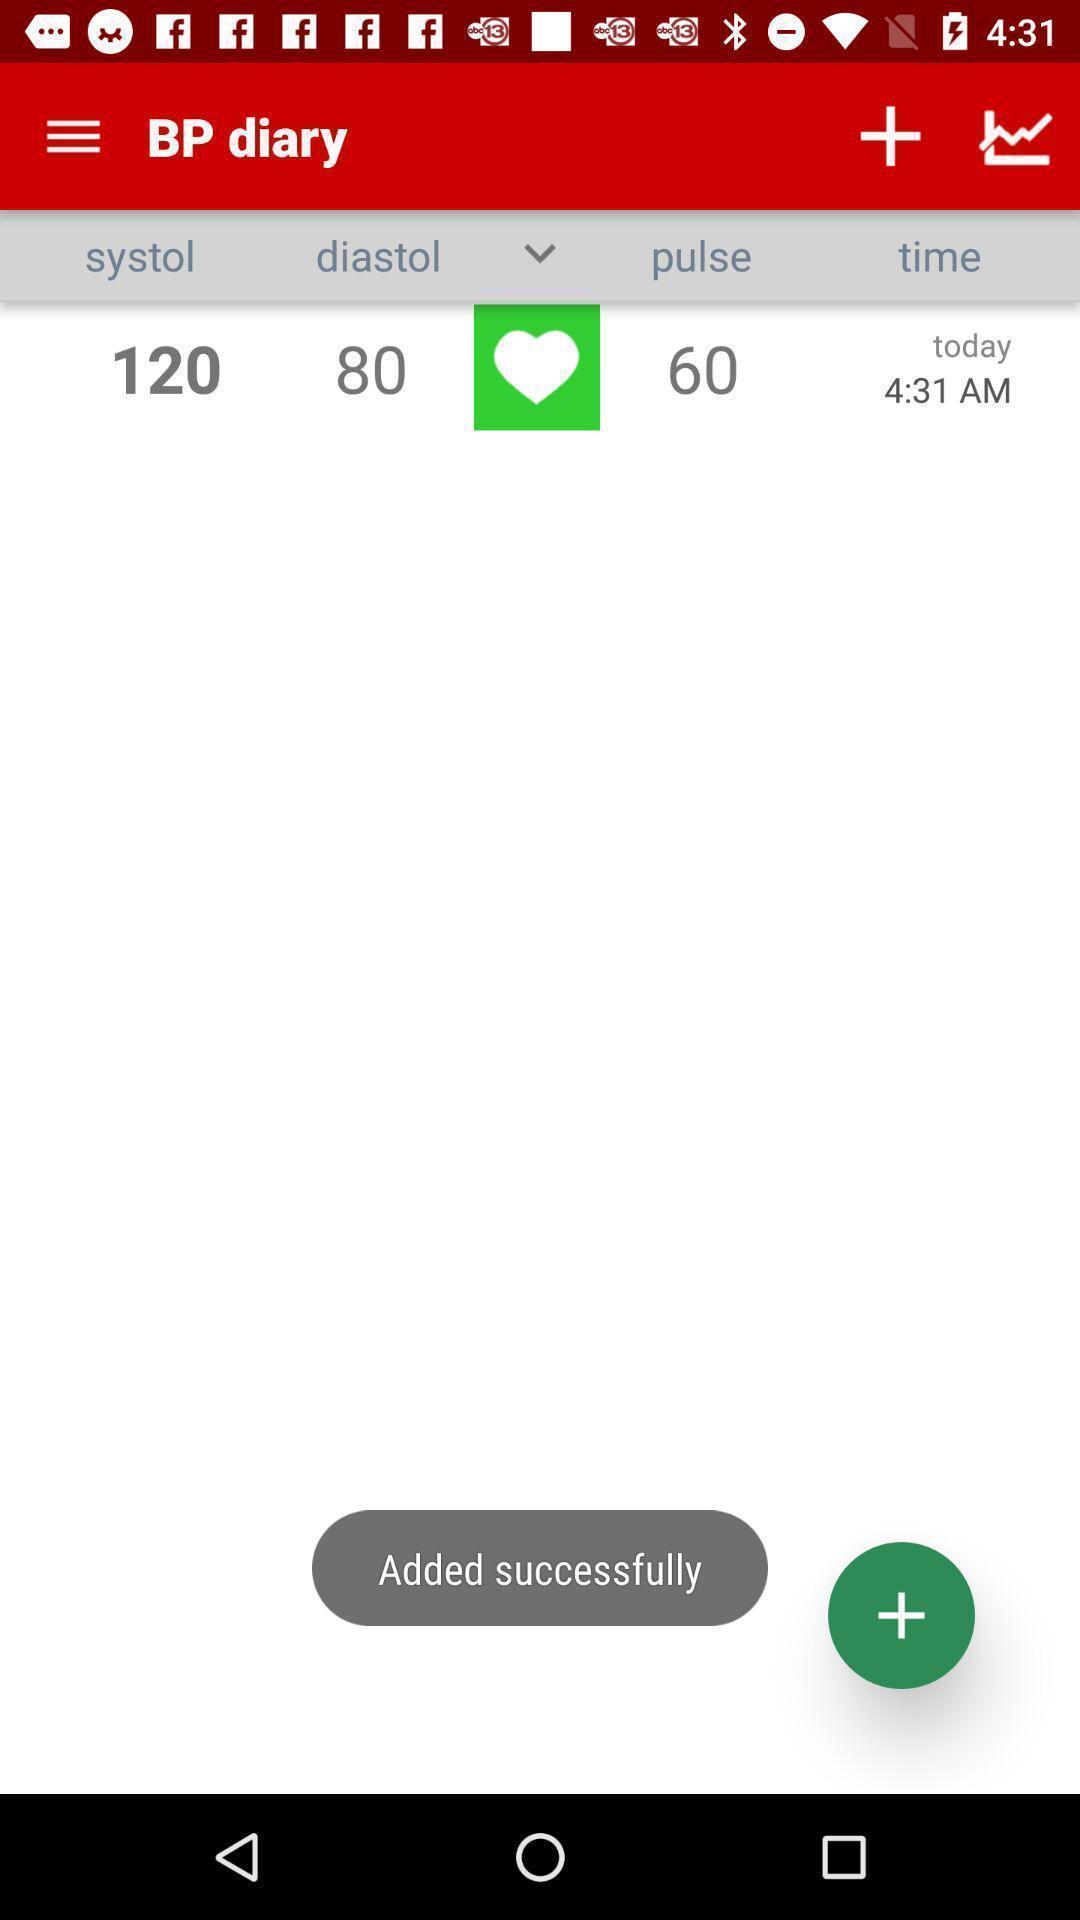Describe the key features of this screenshot. Screen showing dairy of a health app. 